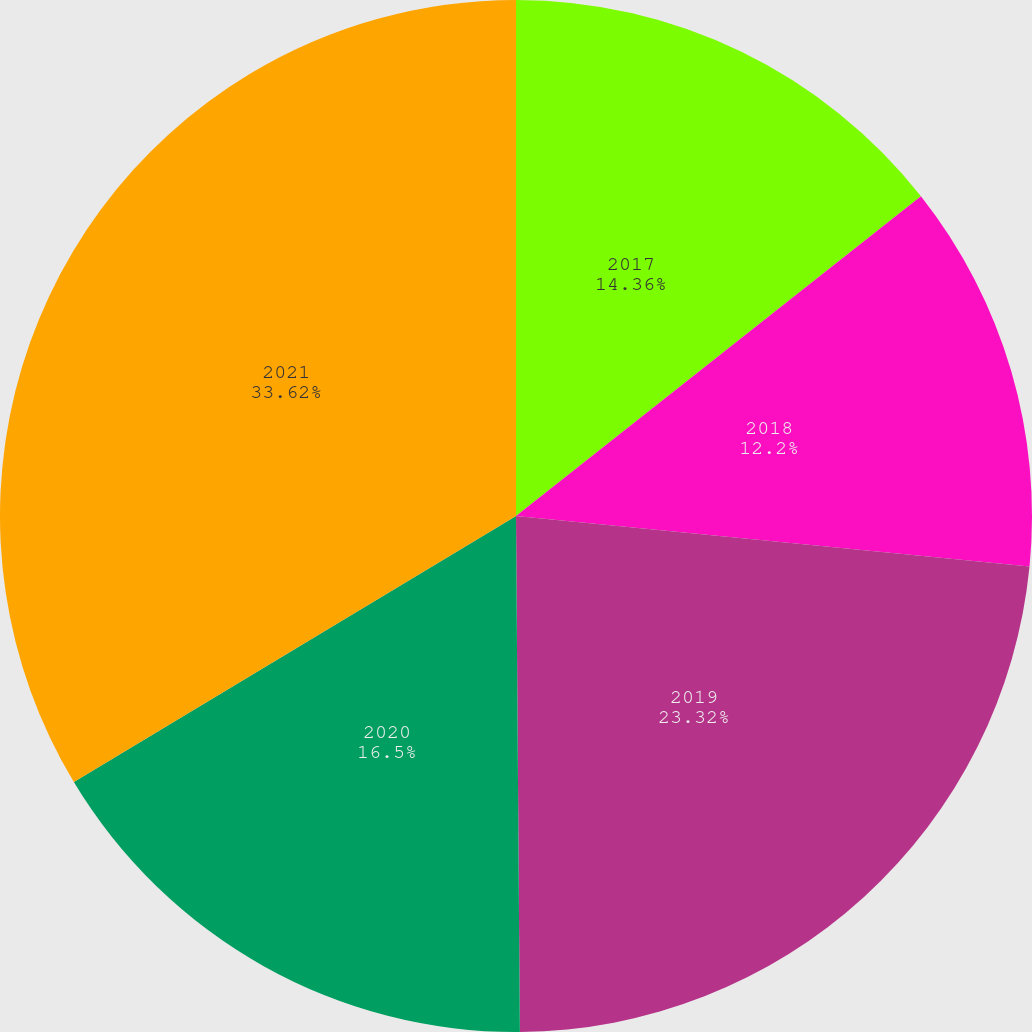Convert chart to OTSL. <chart><loc_0><loc_0><loc_500><loc_500><pie_chart><fcel>2017<fcel>2018<fcel>2019<fcel>2020<fcel>2021<nl><fcel>14.36%<fcel>12.2%<fcel>23.32%<fcel>16.5%<fcel>33.62%<nl></chart> 